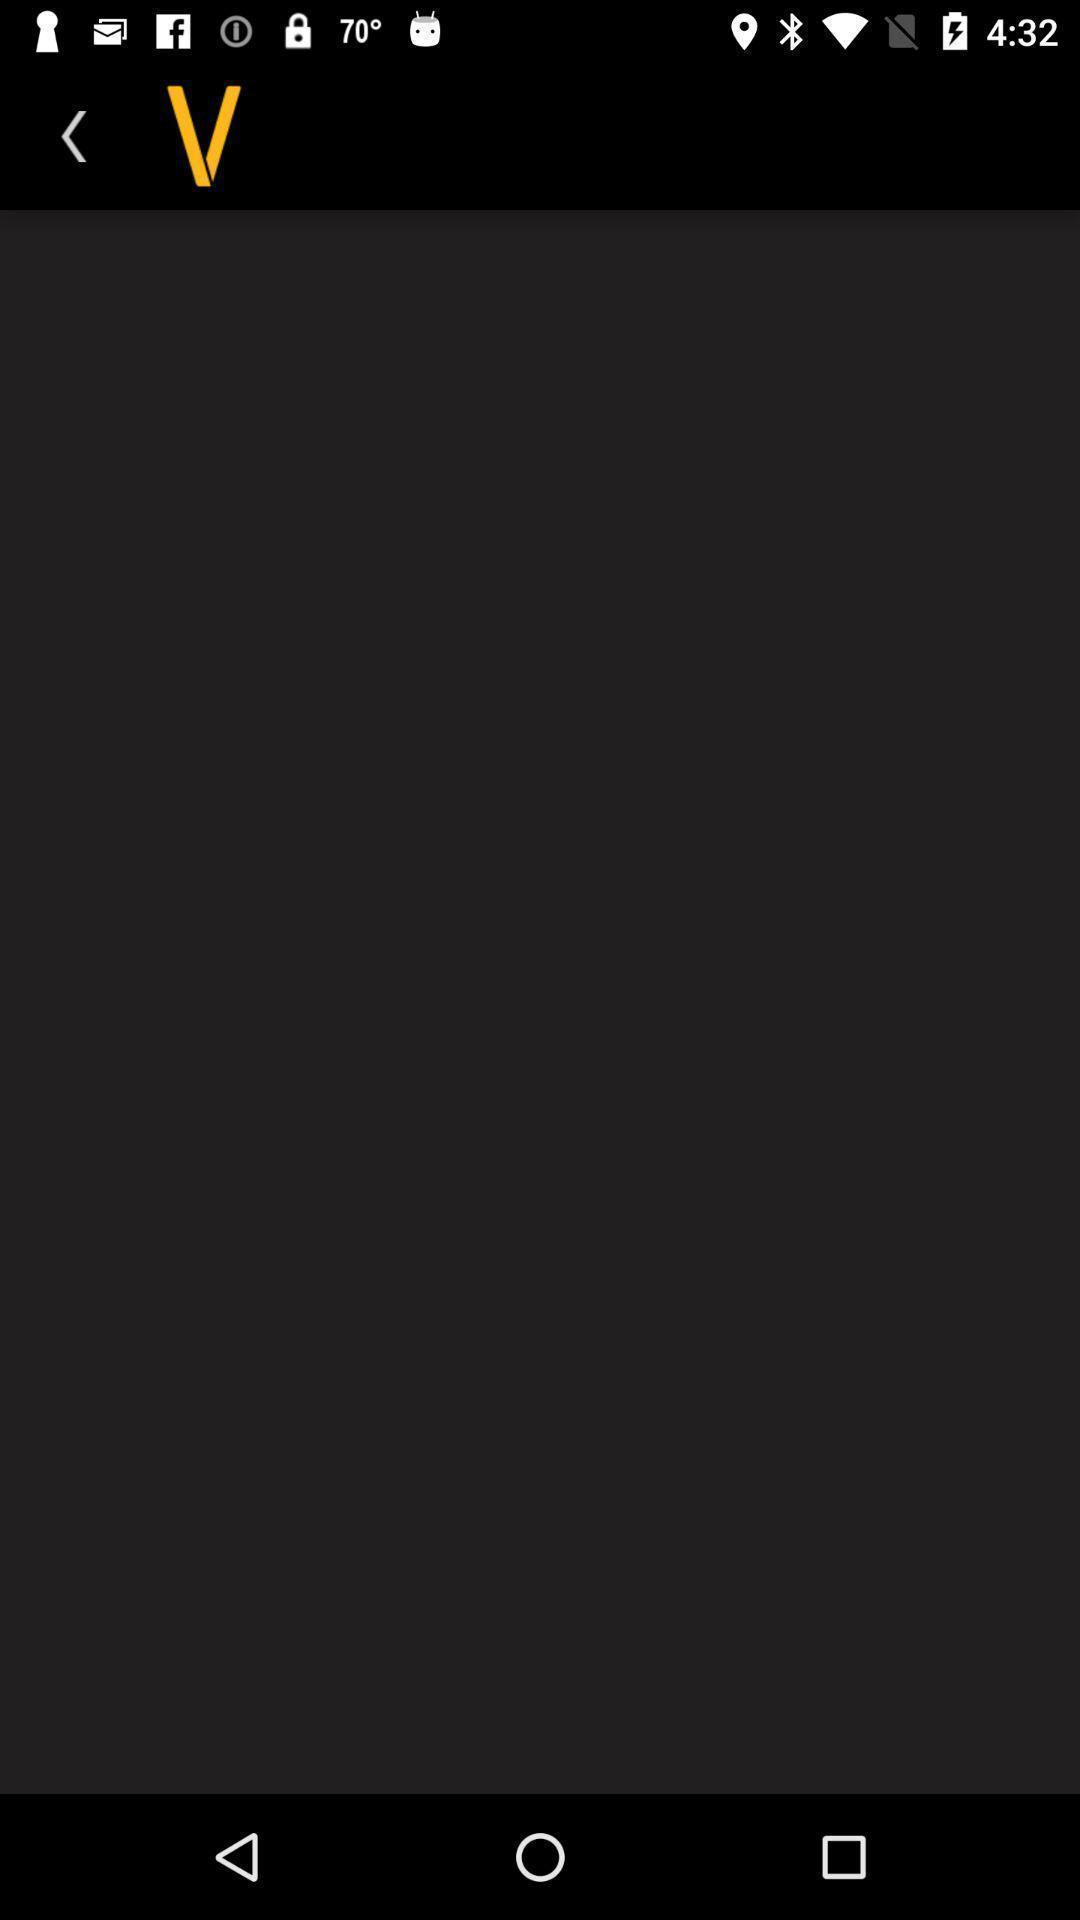Explain what's happening in this screen capture. Screen showing blank page food delivery app. 